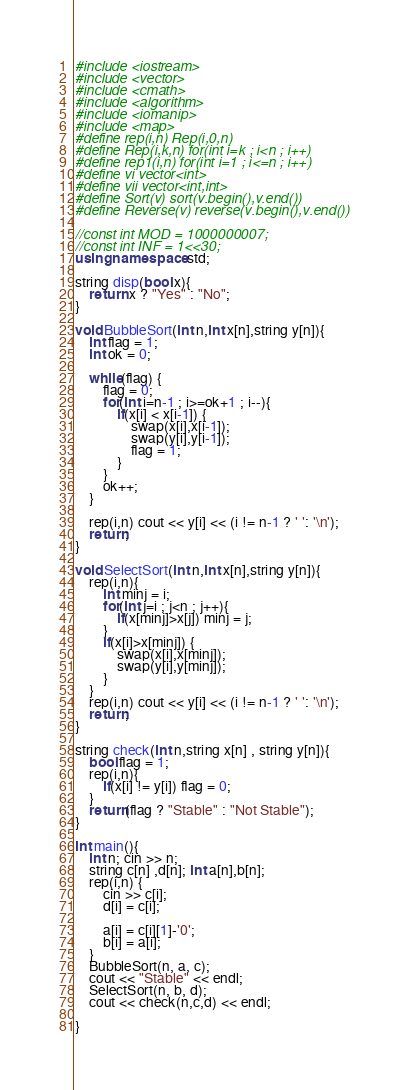<code> <loc_0><loc_0><loc_500><loc_500><_C++_>#include <iostream>
#include <vector>
#include <cmath>
#include <algorithm>
#include <iomanip>
#include <map>
#define rep(i,n) Rep(i,0,n)
#define Rep(i,k,n) for(int i=k ; i<n ; i++)
#define rep1(i,n) for(int i=1 ; i<=n ; i++)
#define vi vector<int>
#define vii vector<int,int>
#define Sort(v) sort(v.begin(),v.end())
#define Reverse(v) reverse(v.begin(),v.end())

//const int MOD = 1000000007;
//const int INF = 1<<30;
using namespace std;

string disp(bool x){
    return x ? "Yes" : "No";
}

void BubbleSort(int n,int x[n],string y[n]){
    int flag = 1;
    int ok = 0;
    
    while(flag) {
        flag = 0;
        for(int i=n-1 ; i>=ok+1 ; i--){
            if(x[i] < x[i-1]) {
                swap(x[i],x[i-1]);
                swap(y[i],y[i-1]);
                flag = 1;
            }
        }
        ok++;
    }
    
    rep(i,n) cout << y[i] << (i != n-1 ? ' ': '\n');
    return;
}

void SelectSort(int n,int x[n],string y[n]){
    rep(i,n){
        int minj = i;
        for(int j=i ; j<n ; j++){
            if(x[minj]>x[j]) minj = j;
        }
        if(x[i]>x[minj]) {
            swap(x[i],x[minj]);
            swap(y[i],y[minj]);
        }
    }
    rep(i,n) cout << y[i] << (i != n-1 ? ' ': '\n');
    return;
}

string check(int n,string x[n] , string y[n]){
    bool flag = 1;
    rep(i,n){
        if(x[i] != y[i]) flag = 0;
    }
    return(flag ? "Stable" : "Not Stable");
}

int main(){
    int n; cin >> n;
    string c[n] ,d[n]; int a[n],b[n];
    rep(i,n) {
        cin >> c[i];
        d[i] = c[i];
        
        a[i] = c[i][1]-'0';
        b[i] = a[i];
    }
    BubbleSort(n, a, c);
    cout << "Stable" << endl;
    SelectSort(n, b, d);
    cout << check(n,c,d) << endl;

}





</code> 